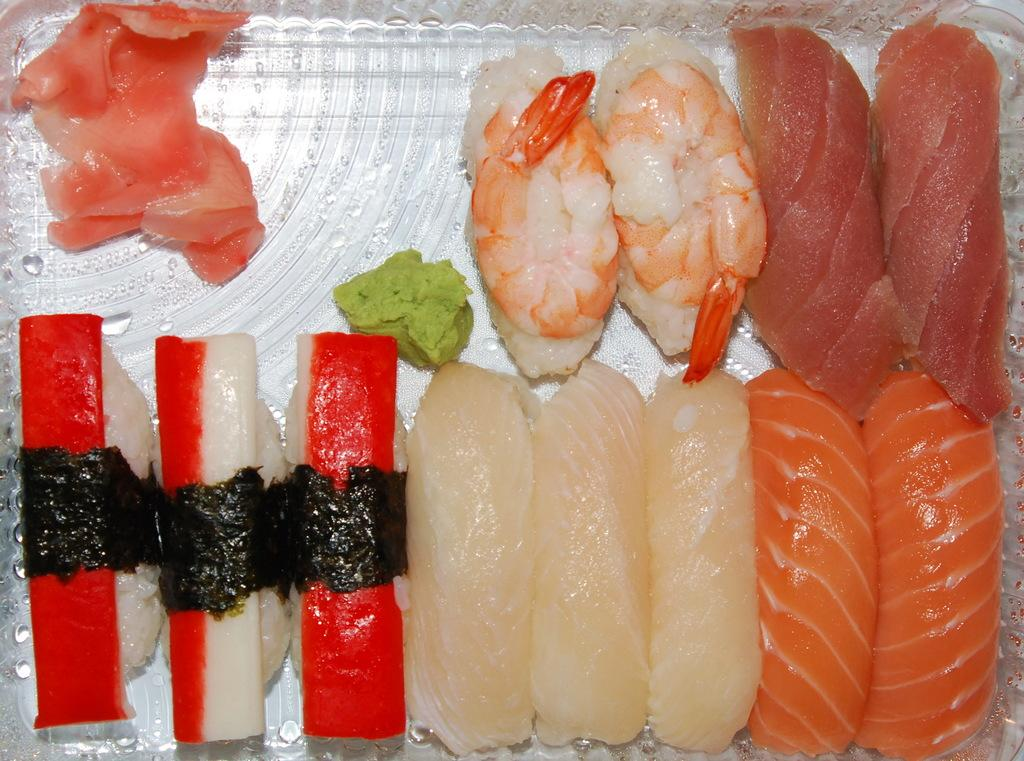What is on the tray in the image? There are food items on a tray in the image. How can the food items be distinguished from one another? The food items have different colors and types. What type of silver is used to make the food items in the image? There is no silver used to make the food items in the image; they are made of various ingredients and materials. 